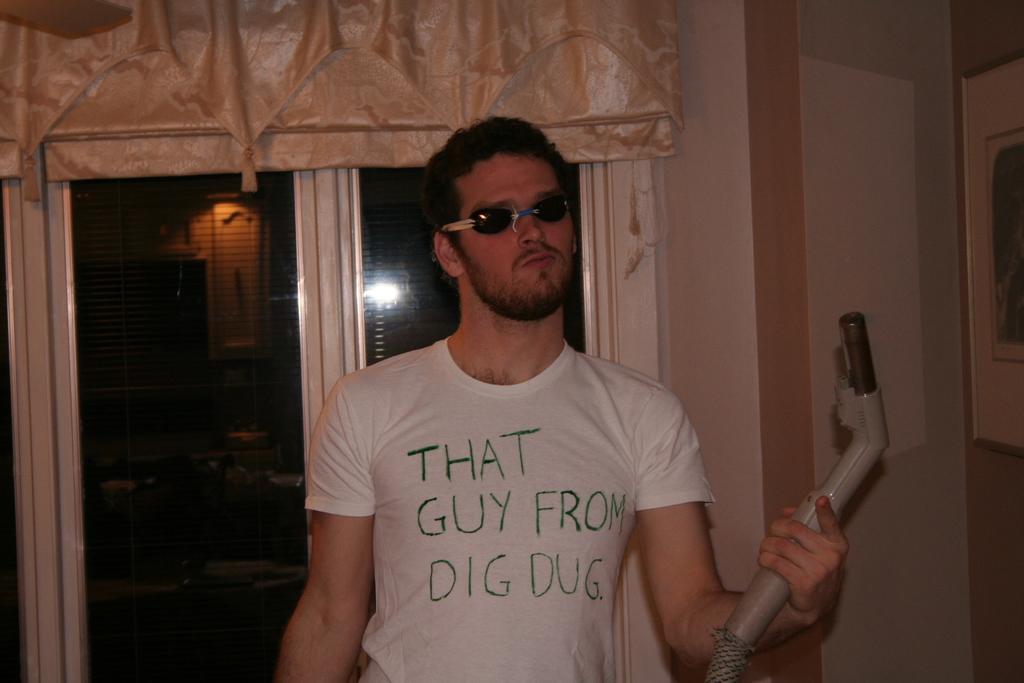Could you give a brief overview of what you see in this image? In the picture I can see a man is standing and holding an object in the hand. The man is wearing glasses and white color t-shirt. In the background I can see a wall, windows and a photo attached to the wall. 